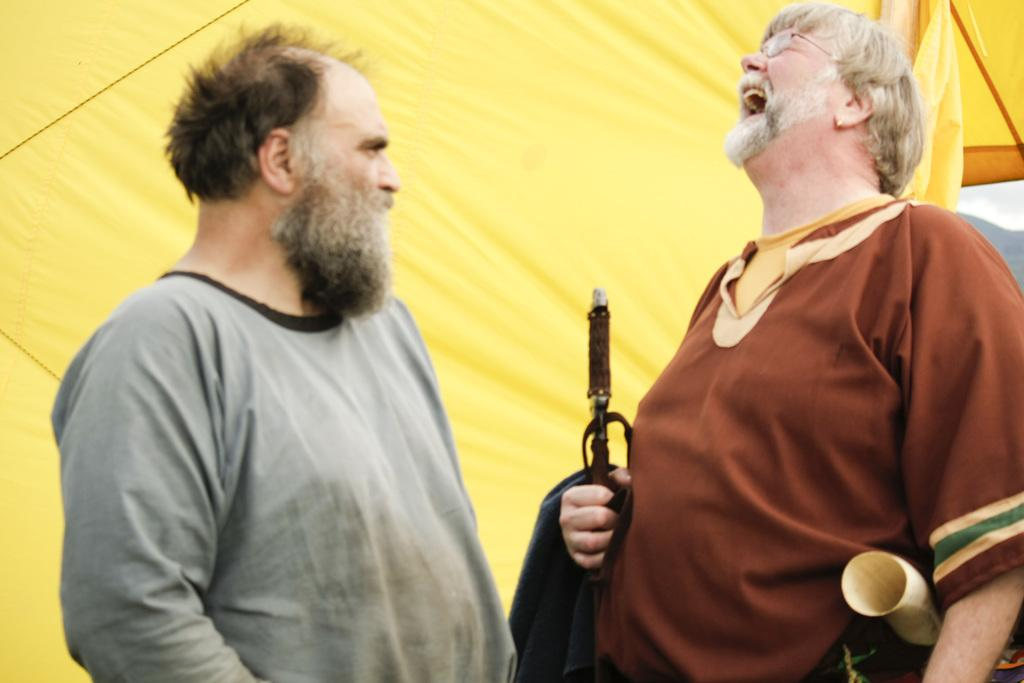How many people are present in the image? There are two people in the image. What can be seen in the background of the image? There is a yellow colored cloth and the sky visible in the background. What type of texture can be seen on the foot of the person in the image? There is no foot visible in the image, so it is not possible to determine the texture of any foot. 